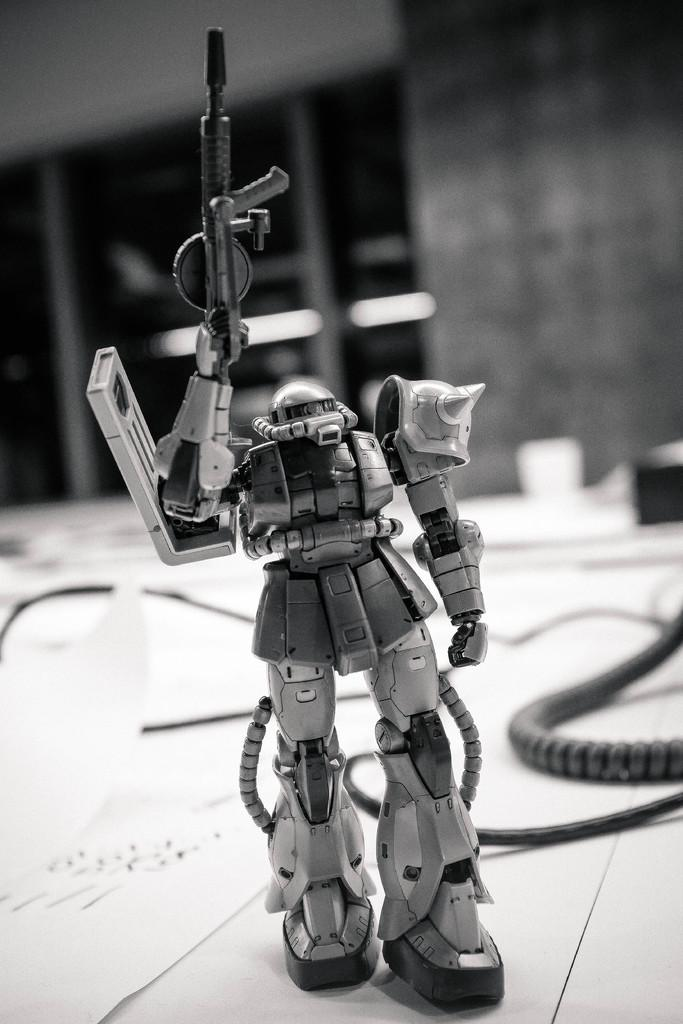What is the color scheme of the image? The image is black and white. What type of toy can be seen in the image? There is a robot toy in the image. Where is the robot toy located in the image? The robot toy is at the bottom of the image. What can be seen in the background of the image? There is a wall in the background of the image. What time of day is it in the image, and are there any horses present? The time of day cannot be determined from the image, as it is black and white and does not provide any clues about the time of day. Additionally, there are no horses present in the image. 